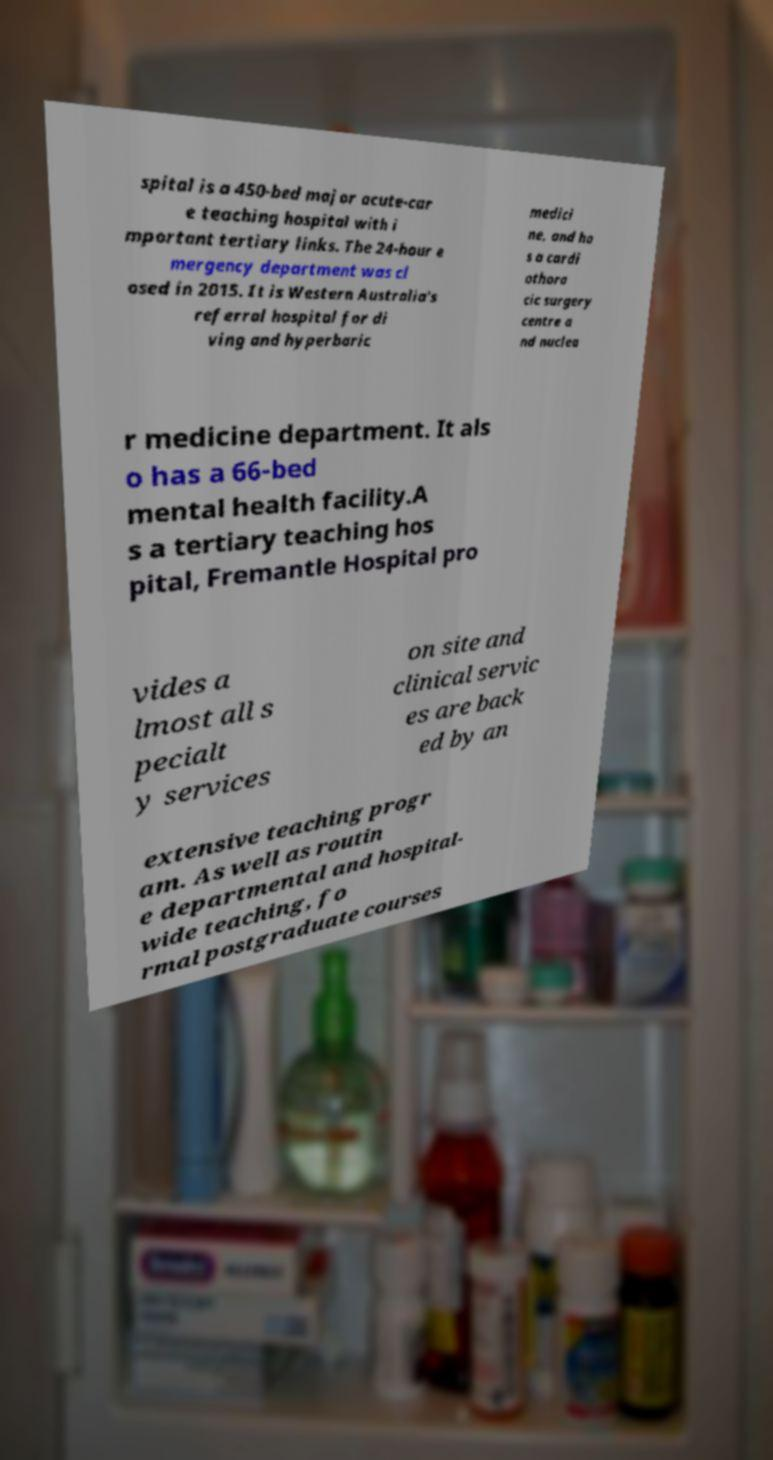I need the written content from this picture converted into text. Can you do that? spital is a 450-bed major acute-car e teaching hospital with i mportant tertiary links. The 24-hour e mergency department was cl osed in 2015. It is Western Australia's referral hospital for di ving and hyperbaric medici ne, and ha s a cardi othora cic surgery centre a nd nuclea r medicine department. It als o has a 66-bed mental health facility.A s a tertiary teaching hos pital, Fremantle Hospital pro vides a lmost all s pecialt y services on site and clinical servic es are back ed by an extensive teaching progr am. As well as routin e departmental and hospital- wide teaching, fo rmal postgraduate courses 